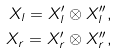Convert formula to latex. <formula><loc_0><loc_0><loc_500><loc_500>X _ { l } = X ^ { \prime } _ { l } \otimes X ^ { \prime \prime } _ { l } , \\ X _ { r } = X ^ { \prime } _ { r } \otimes X ^ { \prime \prime } _ { r } ,</formula> 